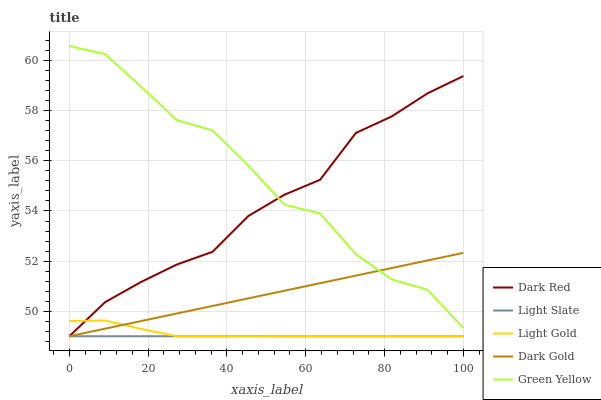Does Dark Red have the minimum area under the curve?
Answer yes or no. No. Does Dark Red have the maximum area under the curve?
Answer yes or no. No. Is Dark Red the smoothest?
Answer yes or no. No. Is Dark Red the roughest?
Answer yes or no. No. Does Green Yellow have the lowest value?
Answer yes or no. No. Does Dark Red have the highest value?
Answer yes or no. No. Is Light Gold less than Green Yellow?
Answer yes or no. Yes. Is Green Yellow greater than Light Slate?
Answer yes or no. Yes. Does Light Gold intersect Green Yellow?
Answer yes or no. No. 